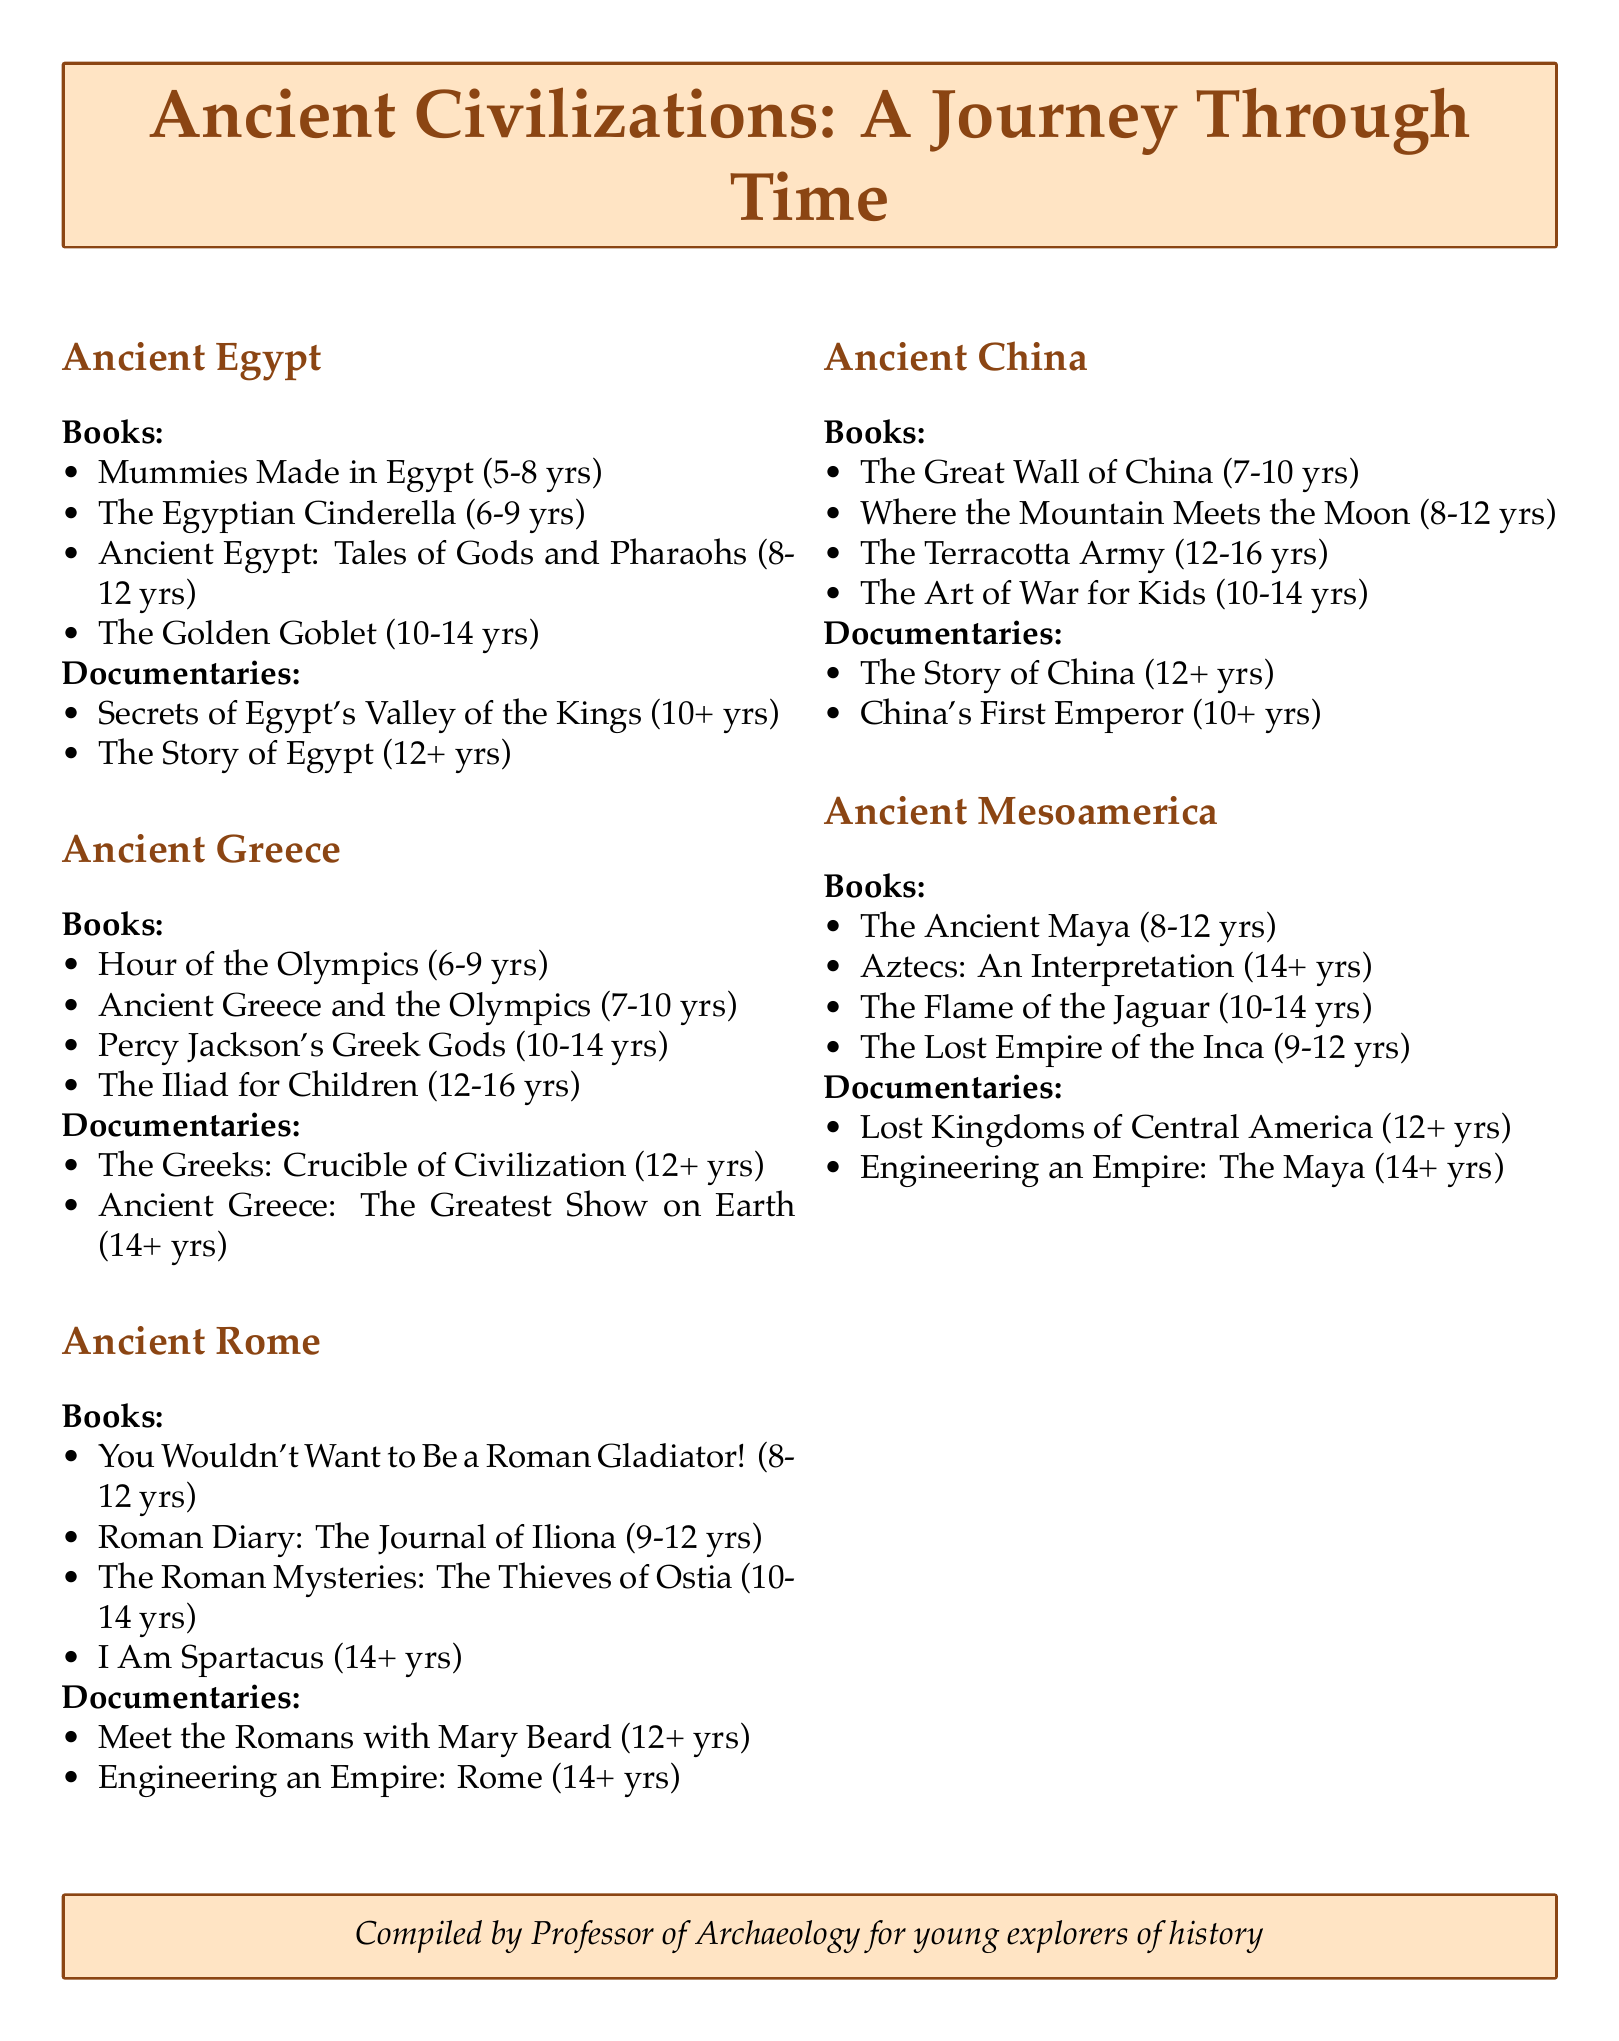What is the title of a book about mummies in Egypt? The title is listed under Ancient Egypt in the document, which includes various books related to that civilization.
Answer: Mummies Made in Egypt Who is the author of "The Egyptian Cinderella"? The author is mentioned in the Ancient Egypt section of the document.
Answer: Shirley Climo What is the age range for the book "Percy Jackson's Greek Gods"? The age range is specified in the Ancient Greece section of the document.
Answer: 10-14 How many episodes are in "The Story of China"? The number of episodes is provided for this documentary in the Ancient China section of the document.
Answer: 6 Which documentary about ancient Rome is presented by Mary Beard? The presenter is listed in the Ancient Rome section of the document that describes the documentaries.
Answer: Meet the Romans with Mary Beard Which ancient civilization has a book titled "Aztecs: An Interpretation"? The book title is found in the Ancient Mesoamerica section of the document.
Answer: Ancient Mesoamerica What is the maximum age range for the books listed under Ancient China? The maximum age range can be deduced by looking at the age range of all books in Ancient China listed in the document.
Answer: 12-16 What historical period includes a book about a Roman gladiator? The historical period is categorized in the document under the books related to that particular civilization.
Answer: Ancient Rome 